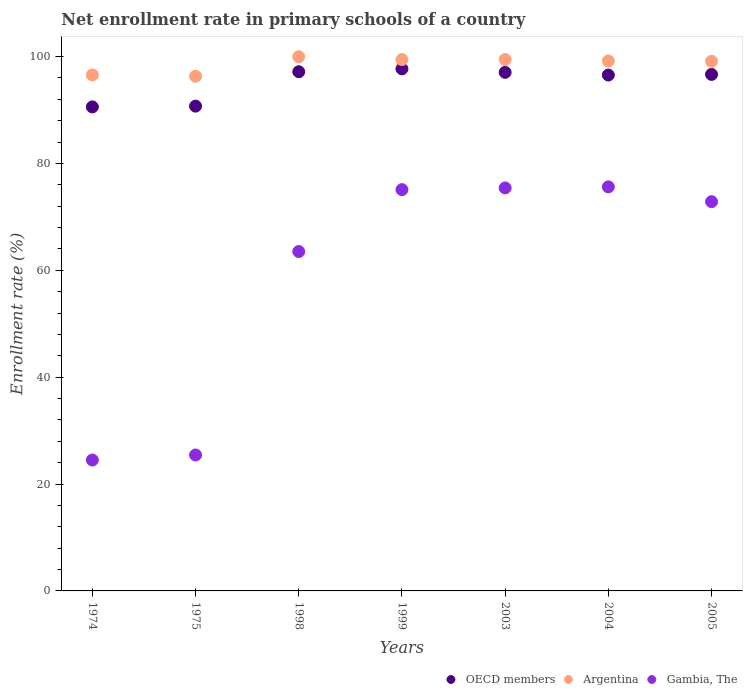How many different coloured dotlines are there?
Your response must be concise. 3. Is the number of dotlines equal to the number of legend labels?
Your answer should be very brief. Yes. What is the enrollment rate in primary schools in Gambia, The in 1999?
Offer a terse response. 75.1. Across all years, what is the maximum enrollment rate in primary schools in Argentina?
Your answer should be compact. 99.96. Across all years, what is the minimum enrollment rate in primary schools in Gambia, The?
Ensure brevity in your answer.  24.49. In which year was the enrollment rate in primary schools in OECD members maximum?
Your response must be concise. 1999. In which year was the enrollment rate in primary schools in Gambia, The minimum?
Provide a short and direct response. 1974. What is the total enrollment rate in primary schools in Argentina in the graph?
Your answer should be very brief. 690. What is the difference between the enrollment rate in primary schools in Argentina in 1998 and that in 2003?
Ensure brevity in your answer.  0.52. What is the difference between the enrollment rate in primary schools in Gambia, The in 1998 and the enrollment rate in primary schools in Argentina in 2005?
Your response must be concise. -35.61. What is the average enrollment rate in primary schools in Argentina per year?
Ensure brevity in your answer.  98.57. In the year 2004, what is the difference between the enrollment rate in primary schools in Argentina and enrollment rate in primary schools in Gambia, The?
Give a very brief answer. 23.56. What is the ratio of the enrollment rate in primary schools in Argentina in 1975 to that in 1999?
Your response must be concise. 0.97. Is the enrollment rate in primary schools in OECD members in 1974 less than that in 2003?
Your answer should be very brief. Yes. What is the difference between the highest and the second highest enrollment rate in primary schools in OECD members?
Provide a succinct answer. 0.54. What is the difference between the highest and the lowest enrollment rate in primary schools in Gambia, The?
Provide a short and direct response. 51.12. Is the sum of the enrollment rate in primary schools in Argentina in 1975 and 2003 greater than the maximum enrollment rate in primary schools in OECD members across all years?
Keep it short and to the point. Yes. Does the enrollment rate in primary schools in Gambia, The monotonically increase over the years?
Offer a very short reply. No. Is the enrollment rate in primary schools in Argentina strictly greater than the enrollment rate in primary schools in Gambia, The over the years?
Keep it short and to the point. Yes. How many years are there in the graph?
Give a very brief answer. 7. How many legend labels are there?
Make the answer very short. 3. How are the legend labels stacked?
Offer a very short reply. Horizontal. What is the title of the graph?
Offer a terse response. Net enrollment rate in primary schools of a country. Does "Cameroon" appear as one of the legend labels in the graph?
Keep it short and to the point. No. What is the label or title of the Y-axis?
Keep it short and to the point. Enrollment rate (%). What is the Enrollment rate (%) of OECD members in 1974?
Make the answer very short. 90.58. What is the Enrollment rate (%) in Argentina in 1974?
Provide a succinct answer. 96.55. What is the Enrollment rate (%) in Gambia, The in 1974?
Provide a succinct answer. 24.49. What is the Enrollment rate (%) in OECD members in 1975?
Ensure brevity in your answer.  90.72. What is the Enrollment rate (%) in Argentina in 1975?
Ensure brevity in your answer.  96.31. What is the Enrollment rate (%) in Gambia, The in 1975?
Make the answer very short. 25.44. What is the Enrollment rate (%) in OECD members in 1998?
Provide a short and direct response. 97.16. What is the Enrollment rate (%) in Argentina in 1998?
Keep it short and to the point. 99.96. What is the Enrollment rate (%) of Gambia, The in 1998?
Give a very brief answer. 63.51. What is the Enrollment rate (%) in OECD members in 1999?
Offer a very short reply. 97.7. What is the Enrollment rate (%) in Argentina in 1999?
Offer a terse response. 99.43. What is the Enrollment rate (%) of Gambia, The in 1999?
Offer a very short reply. 75.1. What is the Enrollment rate (%) of OECD members in 2003?
Your response must be concise. 97.04. What is the Enrollment rate (%) of Argentina in 2003?
Your response must be concise. 99.44. What is the Enrollment rate (%) of Gambia, The in 2003?
Offer a very short reply. 75.41. What is the Enrollment rate (%) in OECD members in 2004?
Your answer should be compact. 96.54. What is the Enrollment rate (%) of Argentina in 2004?
Make the answer very short. 99.18. What is the Enrollment rate (%) in Gambia, The in 2004?
Your answer should be compact. 75.61. What is the Enrollment rate (%) of OECD members in 2005?
Give a very brief answer. 96.66. What is the Enrollment rate (%) of Argentina in 2005?
Your response must be concise. 99.12. What is the Enrollment rate (%) of Gambia, The in 2005?
Your answer should be very brief. 72.84. Across all years, what is the maximum Enrollment rate (%) of OECD members?
Your answer should be very brief. 97.7. Across all years, what is the maximum Enrollment rate (%) of Argentina?
Your response must be concise. 99.96. Across all years, what is the maximum Enrollment rate (%) of Gambia, The?
Your response must be concise. 75.61. Across all years, what is the minimum Enrollment rate (%) in OECD members?
Provide a short and direct response. 90.58. Across all years, what is the minimum Enrollment rate (%) of Argentina?
Provide a short and direct response. 96.31. Across all years, what is the minimum Enrollment rate (%) of Gambia, The?
Provide a succinct answer. 24.49. What is the total Enrollment rate (%) in OECD members in the graph?
Provide a succinct answer. 666.39. What is the total Enrollment rate (%) of Argentina in the graph?
Provide a succinct answer. 690. What is the total Enrollment rate (%) of Gambia, The in the graph?
Your answer should be compact. 412.4. What is the difference between the Enrollment rate (%) of OECD members in 1974 and that in 1975?
Provide a short and direct response. -0.14. What is the difference between the Enrollment rate (%) in Argentina in 1974 and that in 1975?
Keep it short and to the point. 0.24. What is the difference between the Enrollment rate (%) of Gambia, The in 1974 and that in 1975?
Ensure brevity in your answer.  -0.94. What is the difference between the Enrollment rate (%) of OECD members in 1974 and that in 1998?
Offer a very short reply. -6.58. What is the difference between the Enrollment rate (%) of Argentina in 1974 and that in 1998?
Provide a succinct answer. -3.41. What is the difference between the Enrollment rate (%) of Gambia, The in 1974 and that in 1998?
Offer a very short reply. -39.02. What is the difference between the Enrollment rate (%) of OECD members in 1974 and that in 1999?
Provide a short and direct response. -7.12. What is the difference between the Enrollment rate (%) of Argentina in 1974 and that in 1999?
Ensure brevity in your answer.  -2.88. What is the difference between the Enrollment rate (%) of Gambia, The in 1974 and that in 1999?
Your response must be concise. -50.6. What is the difference between the Enrollment rate (%) in OECD members in 1974 and that in 2003?
Give a very brief answer. -6.46. What is the difference between the Enrollment rate (%) in Argentina in 1974 and that in 2003?
Your answer should be compact. -2.89. What is the difference between the Enrollment rate (%) of Gambia, The in 1974 and that in 2003?
Ensure brevity in your answer.  -50.92. What is the difference between the Enrollment rate (%) of OECD members in 1974 and that in 2004?
Keep it short and to the point. -5.96. What is the difference between the Enrollment rate (%) of Argentina in 1974 and that in 2004?
Your response must be concise. -2.63. What is the difference between the Enrollment rate (%) of Gambia, The in 1974 and that in 2004?
Make the answer very short. -51.12. What is the difference between the Enrollment rate (%) in OECD members in 1974 and that in 2005?
Offer a very short reply. -6.08. What is the difference between the Enrollment rate (%) of Argentina in 1974 and that in 2005?
Offer a terse response. -2.57. What is the difference between the Enrollment rate (%) of Gambia, The in 1974 and that in 2005?
Give a very brief answer. -48.35. What is the difference between the Enrollment rate (%) in OECD members in 1975 and that in 1998?
Make the answer very short. -6.44. What is the difference between the Enrollment rate (%) in Argentina in 1975 and that in 1998?
Give a very brief answer. -3.65. What is the difference between the Enrollment rate (%) of Gambia, The in 1975 and that in 1998?
Give a very brief answer. -38.07. What is the difference between the Enrollment rate (%) of OECD members in 1975 and that in 1999?
Your answer should be compact. -6.98. What is the difference between the Enrollment rate (%) in Argentina in 1975 and that in 1999?
Give a very brief answer. -3.12. What is the difference between the Enrollment rate (%) of Gambia, The in 1975 and that in 1999?
Keep it short and to the point. -49.66. What is the difference between the Enrollment rate (%) in OECD members in 1975 and that in 2003?
Make the answer very short. -6.32. What is the difference between the Enrollment rate (%) of Argentina in 1975 and that in 2003?
Provide a succinct answer. -3.14. What is the difference between the Enrollment rate (%) in Gambia, The in 1975 and that in 2003?
Your response must be concise. -49.98. What is the difference between the Enrollment rate (%) in OECD members in 1975 and that in 2004?
Offer a terse response. -5.82. What is the difference between the Enrollment rate (%) of Argentina in 1975 and that in 2004?
Offer a very short reply. -2.87. What is the difference between the Enrollment rate (%) in Gambia, The in 1975 and that in 2004?
Provide a short and direct response. -50.18. What is the difference between the Enrollment rate (%) of OECD members in 1975 and that in 2005?
Your answer should be very brief. -5.94. What is the difference between the Enrollment rate (%) in Argentina in 1975 and that in 2005?
Give a very brief answer. -2.81. What is the difference between the Enrollment rate (%) of Gambia, The in 1975 and that in 2005?
Offer a very short reply. -47.4. What is the difference between the Enrollment rate (%) of OECD members in 1998 and that in 1999?
Provide a succinct answer. -0.54. What is the difference between the Enrollment rate (%) of Argentina in 1998 and that in 1999?
Your answer should be very brief. 0.53. What is the difference between the Enrollment rate (%) of Gambia, The in 1998 and that in 1999?
Your answer should be compact. -11.59. What is the difference between the Enrollment rate (%) in OECD members in 1998 and that in 2003?
Your response must be concise. 0.12. What is the difference between the Enrollment rate (%) in Argentina in 1998 and that in 2003?
Ensure brevity in your answer.  0.52. What is the difference between the Enrollment rate (%) of Gambia, The in 1998 and that in 2003?
Ensure brevity in your answer.  -11.91. What is the difference between the Enrollment rate (%) in OECD members in 1998 and that in 2004?
Provide a short and direct response. 0.62. What is the difference between the Enrollment rate (%) in Argentina in 1998 and that in 2004?
Your answer should be very brief. 0.79. What is the difference between the Enrollment rate (%) in Gambia, The in 1998 and that in 2004?
Your answer should be very brief. -12.1. What is the difference between the Enrollment rate (%) of OECD members in 1998 and that in 2005?
Your response must be concise. 0.5. What is the difference between the Enrollment rate (%) in Argentina in 1998 and that in 2005?
Provide a succinct answer. 0.85. What is the difference between the Enrollment rate (%) of Gambia, The in 1998 and that in 2005?
Provide a succinct answer. -9.33. What is the difference between the Enrollment rate (%) in OECD members in 1999 and that in 2003?
Your answer should be very brief. 0.66. What is the difference between the Enrollment rate (%) in Argentina in 1999 and that in 2003?
Provide a short and direct response. -0.01. What is the difference between the Enrollment rate (%) of Gambia, The in 1999 and that in 2003?
Offer a terse response. -0.32. What is the difference between the Enrollment rate (%) of OECD members in 1999 and that in 2004?
Make the answer very short. 1.16. What is the difference between the Enrollment rate (%) of Argentina in 1999 and that in 2004?
Make the answer very short. 0.26. What is the difference between the Enrollment rate (%) of Gambia, The in 1999 and that in 2004?
Offer a terse response. -0.52. What is the difference between the Enrollment rate (%) of OECD members in 1999 and that in 2005?
Your answer should be very brief. 1.04. What is the difference between the Enrollment rate (%) of Argentina in 1999 and that in 2005?
Make the answer very short. 0.31. What is the difference between the Enrollment rate (%) in Gambia, The in 1999 and that in 2005?
Your answer should be compact. 2.26. What is the difference between the Enrollment rate (%) in OECD members in 2003 and that in 2004?
Make the answer very short. 0.5. What is the difference between the Enrollment rate (%) in Argentina in 2003 and that in 2004?
Offer a very short reply. 0.27. What is the difference between the Enrollment rate (%) of Gambia, The in 2003 and that in 2004?
Your response must be concise. -0.2. What is the difference between the Enrollment rate (%) in OECD members in 2003 and that in 2005?
Your response must be concise. 0.38. What is the difference between the Enrollment rate (%) in Argentina in 2003 and that in 2005?
Your answer should be very brief. 0.33. What is the difference between the Enrollment rate (%) in Gambia, The in 2003 and that in 2005?
Provide a succinct answer. 2.58. What is the difference between the Enrollment rate (%) of OECD members in 2004 and that in 2005?
Provide a short and direct response. -0.12. What is the difference between the Enrollment rate (%) in Argentina in 2004 and that in 2005?
Keep it short and to the point. 0.06. What is the difference between the Enrollment rate (%) in Gambia, The in 2004 and that in 2005?
Give a very brief answer. 2.77. What is the difference between the Enrollment rate (%) of OECD members in 1974 and the Enrollment rate (%) of Argentina in 1975?
Offer a terse response. -5.73. What is the difference between the Enrollment rate (%) in OECD members in 1974 and the Enrollment rate (%) in Gambia, The in 1975?
Keep it short and to the point. 65.14. What is the difference between the Enrollment rate (%) in Argentina in 1974 and the Enrollment rate (%) in Gambia, The in 1975?
Provide a succinct answer. 71.11. What is the difference between the Enrollment rate (%) of OECD members in 1974 and the Enrollment rate (%) of Argentina in 1998?
Give a very brief answer. -9.38. What is the difference between the Enrollment rate (%) of OECD members in 1974 and the Enrollment rate (%) of Gambia, The in 1998?
Your answer should be compact. 27.07. What is the difference between the Enrollment rate (%) in Argentina in 1974 and the Enrollment rate (%) in Gambia, The in 1998?
Offer a terse response. 33.04. What is the difference between the Enrollment rate (%) in OECD members in 1974 and the Enrollment rate (%) in Argentina in 1999?
Offer a terse response. -8.85. What is the difference between the Enrollment rate (%) in OECD members in 1974 and the Enrollment rate (%) in Gambia, The in 1999?
Your response must be concise. 15.49. What is the difference between the Enrollment rate (%) of Argentina in 1974 and the Enrollment rate (%) of Gambia, The in 1999?
Your response must be concise. 21.46. What is the difference between the Enrollment rate (%) in OECD members in 1974 and the Enrollment rate (%) in Argentina in 2003?
Make the answer very short. -8.86. What is the difference between the Enrollment rate (%) of OECD members in 1974 and the Enrollment rate (%) of Gambia, The in 2003?
Offer a terse response. 15.17. What is the difference between the Enrollment rate (%) in Argentina in 1974 and the Enrollment rate (%) in Gambia, The in 2003?
Offer a terse response. 21.14. What is the difference between the Enrollment rate (%) in OECD members in 1974 and the Enrollment rate (%) in Argentina in 2004?
Offer a terse response. -8.6. What is the difference between the Enrollment rate (%) in OECD members in 1974 and the Enrollment rate (%) in Gambia, The in 2004?
Your response must be concise. 14.97. What is the difference between the Enrollment rate (%) of Argentina in 1974 and the Enrollment rate (%) of Gambia, The in 2004?
Your response must be concise. 20.94. What is the difference between the Enrollment rate (%) in OECD members in 1974 and the Enrollment rate (%) in Argentina in 2005?
Give a very brief answer. -8.54. What is the difference between the Enrollment rate (%) in OECD members in 1974 and the Enrollment rate (%) in Gambia, The in 2005?
Offer a very short reply. 17.74. What is the difference between the Enrollment rate (%) in Argentina in 1974 and the Enrollment rate (%) in Gambia, The in 2005?
Offer a very short reply. 23.71. What is the difference between the Enrollment rate (%) in OECD members in 1975 and the Enrollment rate (%) in Argentina in 1998?
Your answer should be very brief. -9.24. What is the difference between the Enrollment rate (%) in OECD members in 1975 and the Enrollment rate (%) in Gambia, The in 1998?
Ensure brevity in your answer.  27.21. What is the difference between the Enrollment rate (%) of Argentina in 1975 and the Enrollment rate (%) of Gambia, The in 1998?
Offer a terse response. 32.8. What is the difference between the Enrollment rate (%) of OECD members in 1975 and the Enrollment rate (%) of Argentina in 1999?
Provide a short and direct response. -8.71. What is the difference between the Enrollment rate (%) of OECD members in 1975 and the Enrollment rate (%) of Gambia, The in 1999?
Your answer should be compact. 15.63. What is the difference between the Enrollment rate (%) in Argentina in 1975 and the Enrollment rate (%) in Gambia, The in 1999?
Offer a very short reply. 21.21. What is the difference between the Enrollment rate (%) in OECD members in 1975 and the Enrollment rate (%) in Argentina in 2003?
Make the answer very short. -8.72. What is the difference between the Enrollment rate (%) of OECD members in 1975 and the Enrollment rate (%) of Gambia, The in 2003?
Make the answer very short. 15.31. What is the difference between the Enrollment rate (%) of Argentina in 1975 and the Enrollment rate (%) of Gambia, The in 2003?
Ensure brevity in your answer.  20.89. What is the difference between the Enrollment rate (%) in OECD members in 1975 and the Enrollment rate (%) in Argentina in 2004?
Your response must be concise. -8.46. What is the difference between the Enrollment rate (%) of OECD members in 1975 and the Enrollment rate (%) of Gambia, The in 2004?
Your response must be concise. 15.11. What is the difference between the Enrollment rate (%) of Argentina in 1975 and the Enrollment rate (%) of Gambia, The in 2004?
Provide a short and direct response. 20.7. What is the difference between the Enrollment rate (%) of OECD members in 1975 and the Enrollment rate (%) of Argentina in 2005?
Keep it short and to the point. -8.4. What is the difference between the Enrollment rate (%) in OECD members in 1975 and the Enrollment rate (%) in Gambia, The in 2005?
Offer a terse response. 17.88. What is the difference between the Enrollment rate (%) of Argentina in 1975 and the Enrollment rate (%) of Gambia, The in 2005?
Ensure brevity in your answer.  23.47. What is the difference between the Enrollment rate (%) in OECD members in 1998 and the Enrollment rate (%) in Argentina in 1999?
Keep it short and to the point. -2.27. What is the difference between the Enrollment rate (%) in OECD members in 1998 and the Enrollment rate (%) in Gambia, The in 1999?
Make the answer very short. 22.06. What is the difference between the Enrollment rate (%) of Argentina in 1998 and the Enrollment rate (%) of Gambia, The in 1999?
Provide a short and direct response. 24.87. What is the difference between the Enrollment rate (%) of OECD members in 1998 and the Enrollment rate (%) of Argentina in 2003?
Your answer should be very brief. -2.29. What is the difference between the Enrollment rate (%) of OECD members in 1998 and the Enrollment rate (%) of Gambia, The in 2003?
Keep it short and to the point. 21.74. What is the difference between the Enrollment rate (%) in Argentina in 1998 and the Enrollment rate (%) in Gambia, The in 2003?
Provide a succinct answer. 24.55. What is the difference between the Enrollment rate (%) in OECD members in 1998 and the Enrollment rate (%) in Argentina in 2004?
Your response must be concise. -2.02. What is the difference between the Enrollment rate (%) of OECD members in 1998 and the Enrollment rate (%) of Gambia, The in 2004?
Provide a succinct answer. 21.55. What is the difference between the Enrollment rate (%) in Argentina in 1998 and the Enrollment rate (%) in Gambia, The in 2004?
Make the answer very short. 24.35. What is the difference between the Enrollment rate (%) of OECD members in 1998 and the Enrollment rate (%) of Argentina in 2005?
Provide a succinct answer. -1.96. What is the difference between the Enrollment rate (%) in OECD members in 1998 and the Enrollment rate (%) in Gambia, The in 2005?
Your answer should be very brief. 24.32. What is the difference between the Enrollment rate (%) in Argentina in 1998 and the Enrollment rate (%) in Gambia, The in 2005?
Provide a short and direct response. 27.12. What is the difference between the Enrollment rate (%) in OECD members in 1999 and the Enrollment rate (%) in Argentina in 2003?
Provide a short and direct response. -1.75. What is the difference between the Enrollment rate (%) of OECD members in 1999 and the Enrollment rate (%) of Gambia, The in 2003?
Make the answer very short. 22.28. What is the difference between the Enrollment rate (%) in Argentina in 1999 and the Enrollment rate (%) in Gambia, The in 2003?
Your answer should be very brief. 24.02. What is the difference between the Enrollment rate (%) of OECD members in 1999 and the Enrollment rate (%) of Argentina in 2004?
Offer a very short reply. -1.48. What is the difference between the Enrollment rate (%) of OECD members in 1999 and the Enrollment rate (%) of Gambia, The in 2004?
Your answer should be compact. 22.09. What is the difference between the Enrollment rate (%) in Argentina in 1999 and the Enrollment rate (%) in Gambia, The in 2004?
Offer a terse response. 23.82. What is the difference between the Enrollment rate (%) of OECD members in 1999 and the Enrollment rate (%) of Argentina in 2005?
Make the answer very short. -1.42. What is the difference between the Enrollment rate (%) of OECD members in 1999 and the Enrollment rate (%) of Gambia, The in 2005?
Provide a succinct answer. 24.86. What is the difference between the Enrollment rate (%) in Argentina in 1999 and the Enrollment rate (%) in Gambia, The in 2005?
Provide a succinct answer. 26.59. What is the difference between the Enrollment rate (%) of OECD members in 2003 and the Enrollment rate (%) of Argentina in 2004?
Your answer should be very brief. -2.14. What is the difference between the Enrollment rate (%) in OECD members in 2003 and the Enrollment rate (%) in Gambia, The in 2004?
Provide a short and direct response. 21.43. What is the difference between the Enrollment rate (%) in Argentina in 2003 and the Enrollment rate (%) in Gambia, The in 2004?
Offer a very short reply. 23.83. What is the difference between the Enrollment rate (%) of OECD members in 2003 and the Enrollment rate (%) of Argentina in 2005?
Your response must be concise. -2.08. What is the difference between the Enrollment rate (%) in OECD members in 2003 and the Enrollment rate (%) in Gambia, The in 2005?
Make the answer very short. 24.2. What is the difference between the Enrollment rate (%) of Argentina in 2003 and the Enrollment rate (%) of Gambia, The in 2005?
Make the answer very short. 26.61. What is the difference between the Enrollment rate (%) in OECD members in 2004 and the Enrollment rate (%) in Argentina in 2005?
Your answer should be compact. -2.58. What is the difference between the Enrollment rate (%) in OECD members in 2004 and the Enrollment rate (%) in Gambia, The in 2005?
Your answer should be very brief. 23.7. What is the difference between the Enrollment rate (%) of Argentina in 2004 and the Enrollment rate (%) of Gambia, The in 2005?
Your answer should be compact. 26.34. What is the average Enrollment rate (%) in OECD members per year?
Make the answer very short. 95.2. What is the average Enrollment rate (%) in Argentina per year?
Make the answer very short. 98.57. What is the average Enrollment rate (%) of Gambia, The per year?
Provide a short and direct response. 58.91. In the year 1974, what is the difference between the Enrollment rate (%) in OECD members and Enrollment rate (%) in Argentina?
Offer a very short reply. -5.97. In the year 1974, what is the difference between the Enrollment rate (%) of OECD members and Enrollment rate (%) of Gambia, The?
Keep it short and to the point. 66.09. In the year 1974, what is the difference between the Enrollment rate (%) in Argentina and Enrollment rate (%) in Gambia, The?
Provide a short and direct response. 72.06. In the year 1975, what is the difference between the Enrollment rate (%) in OECD members and Enrollment rate (%) in Argentina?
Make the answer very short. -5.59. In the year 1975, what is the difference between the Enrollment rate (%) in OECD members and Enrollment rate (%) in Gambia, The?
Offer a very short reply. 65.28. In the year 1975, what is the difference between the Enrollment rate (%) in Argentina and Enrollment rate (%) in Gambia, The?
Provide a short and direct response. 70.87. In the year 1998, what is the difference between the Enrollment rate (%) in OECD members and Enrollment rate (%) in Argentina?
Provide a short and direct response. -2.81. In the year 1998, what is the difference between the Enrollment rate (%) of OECD members and Enrollment rate (%) of Gambia, The?
Your answer should be very brief. 33.65. In the year 1998, what is the difference between the Enrollment rate (%) of Argentina and Enrollment rate (%) of Gambia, The?
Offer a terse response. 36.45. In the year 1999, what is the difference between the Enrollment rate (%) in OECD members and Enrollment rate (%) in Argentina?
Your answer should be compact. -1.73. In the year 1999, what is the difference between the Enrollment rate (%) of OECD members and Enrollment rate (%) of Gambia, The?
Your response must be concise. 22.6. In the year 1999, what is the difference between the Enrollment rate (%) in Argentina and Enrollment rate (%) in Gambia, The?
Your response must be concise. 24.34. In the year 2003, what is the difference between the Enrollment rate (%) in OECD members and Enrollment rate (%) in Argentina?
Make the answer very short. -2.4. In the year 2003, what is the difference between the Enrollment rate (%) of OECD members and Enrollment rate (%) of Gambia, The?
Your answer should be very brief. 21.63. In the year 2003, what is the difference between the Enrollment rate (%) in Argentina and Enrollment rate (%) in Gambia, The?
Offer a very short reply. 24.03. In the year 2004, what is the difference between the Enrollment rate (%) of OECD members and Enrollment rate (%) of Argentina?
Your answer should be compact. -2.64. In the year 2004, what is the difference between the Enrollment rate (%) of OECD members and Enrollment rate (%) of Gambia, The?
Your answer should be compact. 20.92. In the year 2004, what is the difference between the Enrollment rate (%) of Argentina and Enrollment rate (%) of Gambia, The?
Provide a succinct answer. 23.56. In the year 2005, what is the difference between the Enrollment rate (%) in OECD members and Enrollment rate (%) in Argentina?
Provide a succinct answer. -2.46. In the year 2005, what is the difference between the Enrollment rate (%) in OECD members and Enrollment rate (%) in Gambia, The?
Your answer should be compact. 23.82. In the year 2005, what is the difference between the Enrollment rate (%) of Argentina and Enrollment rate (%) of Gambia, The?
Offer a terse response. 26.28. What is the ratio of the Enrollment rate (%) in OECD members in 1974 to that in 1975?
Offer a terse response. 1. What is the ratio of the Enrollment rate (%) of Gambia, The in 1974 to that in 1975?
Offer a very short reply. 0.96. What is the ratio of the Enrollment rate (%) in OECD members in 1974 to that in 1998?
Keep it short and to the point. 0.93. What is the ratio of the Enrollment rate (%) of Argentina in 1974 to that in 1998?
Your answer should be compact. 0.97. What is the ratio of the Enrollment rate (%) in Gambia, The in 1974 to that in 1998?
Ensure brevity in your answer.  0.39. What is the ratio of the Enrollment rate (%) of OECD members in 1974 to that in 1999?
Offer a very short reply. 0.93. What is the ratio of the Enrollment rate (%) in Argentina in 1974 to that in 1999?
Your answer should be compact. 0.97. What is the ratio of the Enrollment rate (%) of Gambia, The in 1974 to that in 1999?
Provide a succinct answer. 0.33. What is the ratio of the Enrollment rate (%) in OECD members in 1974 to that in 2003?
Provide a succinct answer. 0.93. What is the ratio of the Enrollment rate (%) of Argentina in 1974 to that in 2003?
Give a very brief answer. 0.97. What is the ratio of the Enrollment rate (%) of Gambia, The in 1974 to that in 2003?
Provide a short and direct response. 0.32. What is the ratio of the Enrollment rate (%) of OECD members in 1974 to that in 2004?
Keep it short and to the point. 0.94. What is the ratio of the Enrollment rate (%) in Argentina in 1974 to that in 2004?
Make the answer very short. 0.97. What is the ratio of the Enrollment rate (%) of Gambia, The in 1974 to that in 2004?
Provide a short and direct response. 0.32. What is the ratio of the Enrollment rate (%) in OECD members in 1974 to that in 2005?
Give a very brief answer. 0.94. What is the ratio of the Enrollment rate (%) of Argentina in 1974 to that in 2005?
Provide a succinct answer. 0.97. What is the ratio of the Enrollment rate (%) of Gambia, The in 1974 to that in 2005?
Your answer should be compact. 0.34. What is the ratio of the Enrollment rate (%) in OECD members in 1975 to that in 1998?
Offer a terse response. 0.93. What is the ratio of the Enrollment rate (%) in Argentina in 1975 to that in 1998?
Ensure brevity in your answer.  0.96. What is the ratio of the Enrollment rate (%) of Gambia, The in 1975 to that in 1998?
Your response must be concise. 0.4. What is the ratio of the Enrollment rate (%) in OECD members in 1975 to that in 1999?
Your answer should be very brief. 0.93. What is the ratio of the Enrollment rate (%) in Argentina in 1975 to that in 1999?
Your answer should be very brief. 0.97. What is the ratio of the Enrollment rate (%) of Gambia, The in 1975 to that in 1999?
Ensure brevity in your answer.  0.34. What is the ratio of the Enrollment rate (%) of OECD members in 1975 to that in 2003?
Offer a terse response. 0.93. What is the ratio of the Enrollment rate (%) in Argentina in 1975 to that in 2003?
Your answer should be very brief. 0.97. What is the ratio of the Enrollment rate (%) in Gambia, The in 1975 to that in 2003?
Give a very brief answer. 0.34. What is the ratio of the Enrollment rate (%) in OECD members in 1975 to that in 2004?
Your response must be concise. 0.94. What is the ratio of the Enrollment rate (%) in Argentina in 1975 to that in 2004?
Give a very brief answer. 0.97. What is the ratio of the Enrollment rate (%) of Gambia, The in 1975 to that in 2004?
Give a very brief answer. 0.34. What is the ratio of the Enrollment rate (%) in OECD members in 1975 to that in 2005?
Offer a terse response. 0.94. What is the ratio of the Enrollment rate (%) in Argentina in 1975 to that in 2005?
Provide a succinct answer. 0.97. What is the ratio of the Enrollment rate (%) of Gambia, The in 1975 to that in 2005?
Provide a succinct answer. 0.35. What is the ratio of the Enrollment rate (%) of Argentina in 1998 to that in 1999?
Provide a short and direct response. 1.01. What is the ratio of the Enrollment rate (%) in Gambia, The in 1998 to that in 1999?
Offer a very short reply. 0.85. What is the ratio of the Enrollment rate (%) in OECD members in 1998 to that in 2003?
Your answer should be compact. 1. What is the ratio of the Enrollment rate (%) in Gambia, The in 1998 to that in 2003?
Keep it short and to the point. 0.84. What is the ratio of the Enrollment rate (%) in OECD members in 1998 to that in 2004?
Provide a succinct answer. 1.01. What is the ratio of the Enrollment rate (%) of Argentina in 1998 to that in 2004?
Make the answer very short. 1.01. What is the ratio of the Enrollment rate (%) in Gambia, The in 1998 to that in 2004?
Ensure brevity in your answer.  0.84. What is the ratio of the Enrollment rate (%) in OECD members in 1998 to that in 2005?
Your response must be concise. 1.01. What is the ratio of the Enrollment rate (%) of Argentina in 1998 to that in 2005?
Your response must be concise. 1.01. What is the ratio of the Enrollment rate (%) of Gambia, The in 1998 to that in 2005?
Your response must be concise. 0.87. What is the ratio of the Enrollment rate (%) of OECD members in 1999 to that in 2003?
Offer a terse response. 1.01. What is the ratio of the Enrollment rate (%) of Gambia, The in 1999 to that in 2003?
Provide a short and direct response. 1. What is the ratio of the Enrollment rate (%) of OECD members in 1999 to that in 2004?
Offer a terse response. 1.01. What is the ratio of the Enrollment rate (%) in OECD members in 1999 to that in 2005?
Provide a succinct answer. 1.01. What is the ratio of the Enrollment rate (%) of Gambia, The in 1999 to that in 2005?
Your answer should be compact. 1.03. What is the ratio of the Enrollment rate (%) of OECD members in 2003 to that in 2005?
Give a very brief answer. 1. What is the ratio of the Enrollment rate (%) of Gambia, The in 2003 to that in 2005?
Your answer should be very brief. 1.04. What is the ratio of the Enrollment rate (%) in Argentina in 2004 to that in 2005?
Provide a short and direct response. 1. What is the ratio of the Enrollment rate (%) in Gambia, The in 2004 to that in 2005?
Offer a very short reply. 1.04. What is the difference between the highest and the second highest Enrollment rate (%) of OECD members?
Keep it short and to the point. 0.54. What is the difference between the highest and the second highest Enrollment rate (%) of Argentina?
Provide a succinct answer. 0.52. What is the difference between the highest and the second highest Enrollment rate (%) of Gambia, The?
Provide a short and direct response. 0.2. What is the difference between the highest and the lowest Enrollment rate (%) in OECD members?
Offer a terse response. 7.12. What is the difference between the highest and the lowest Enrollment rate (%) of Argentina?
Your response must be concise. 3.65. What is the difference between the highest and the lowest Enrollment rate (%) of Gambia, The?
Make the answer very short. 51.12. 